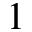<formula> <loc_0><loc_0><loc_500><loc_500>1</formula> 